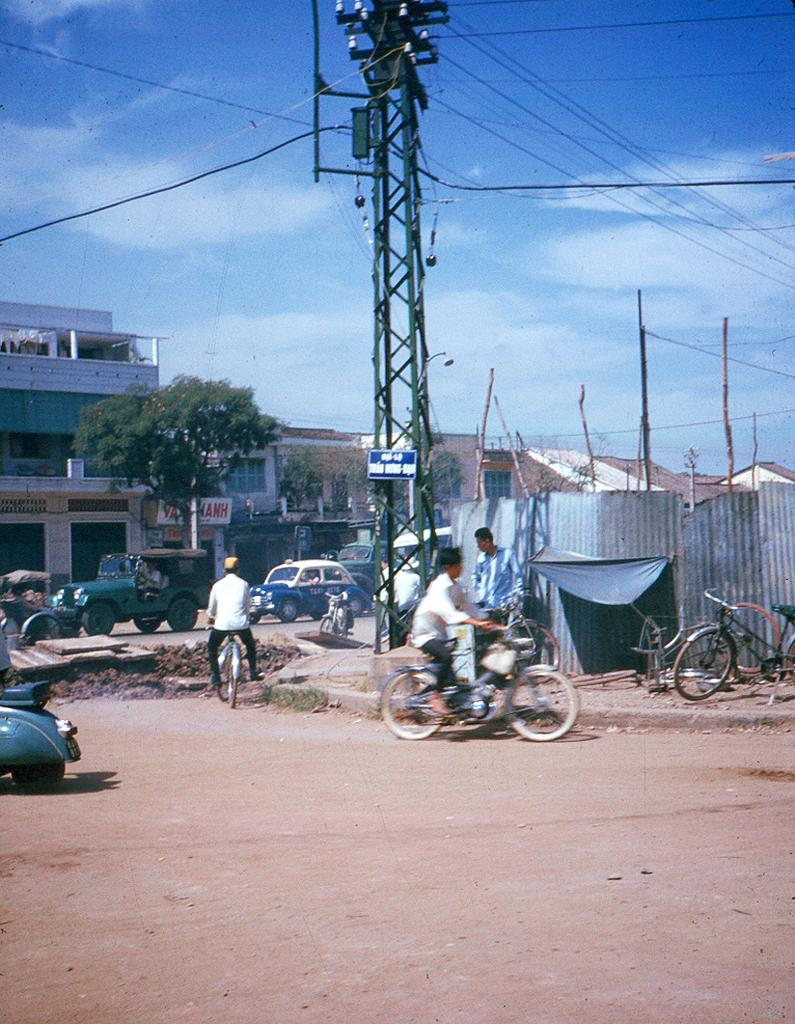What type of transportation can be seen in the image? There are bicycles and vehicles in the image. Who or what is present in the image? There are people in the image. What type of natural elements can be seen in the image? Trees are present in the image. What type of man-made structures can be seen in the image? Buildings are visible in the image. What is the purpose of the pole in the image? The pole's purpose is not specified in the image, but it could be for signage or lighting. What is visible in the background of the image? The sky is visible in the background of the image. What language is being spoken by the people in the image? The image does not provide any information about the language being spoken by the people. What type of recess is visible in the image? There is no recess present in the image. 